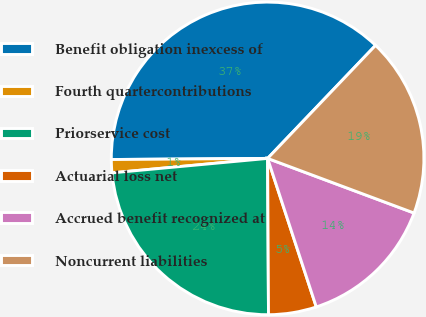Convert chart to OTSL. <chart><loc_0><loc_0><loc_500><loc_500><pie_chart><fcel>Benefit obligation inexcess of<fcel>Fourth quartercontributions<fcel>Priorservice cost<fcel>Actuarial loss net<fcel>Accrued benefit recognized at<fcel>Noncurrent liabilities<nl><fcel>37.25%<fcel>1.36%<fcel>23.62%<fcel>4.95%<fcel>14.28%<fcel>18.55%<nl></chart> 